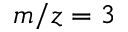<formula> <loc_0><loc_0><loc_500><loc_500>m / z = 3</formula> 